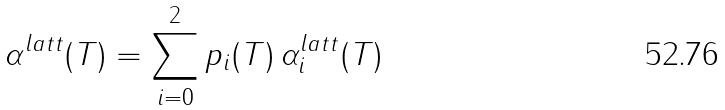<formula> <loc_0><loc_0><loc_500><loc_500>\alpha ^ { l a t t } ( T ) = \sum _ { i = 0 } ^ { 2 } p _ { i } ( T ) \, \alpha ^ { l a t t } _ { i } ( T )</formula> 